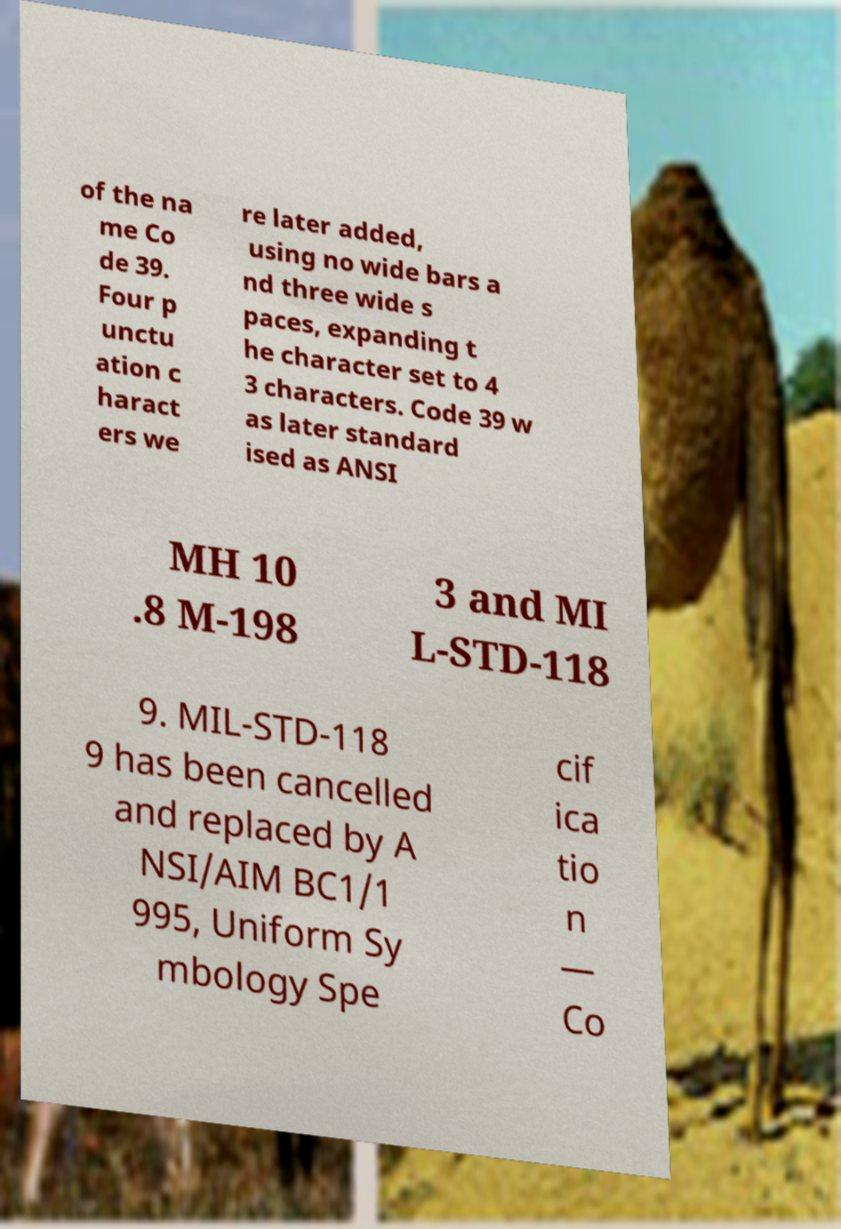Could you extract and type out the text from this image? of the na me Co de 39. Four p unctu ation c haract ers we re later added, using no wide bars a nd three wide s paces, expanding t he character set to 4 3 characters. Code 39 w as later standard ised as ANSI MH 10 .8 M-198 3 and MI L-STD-118 9. MIL-STD-118 9 has been cancelled and replaced by A NSI/AIM BC1/1 995, Uniform Sy mbology Spe cif ica tio n — Co 